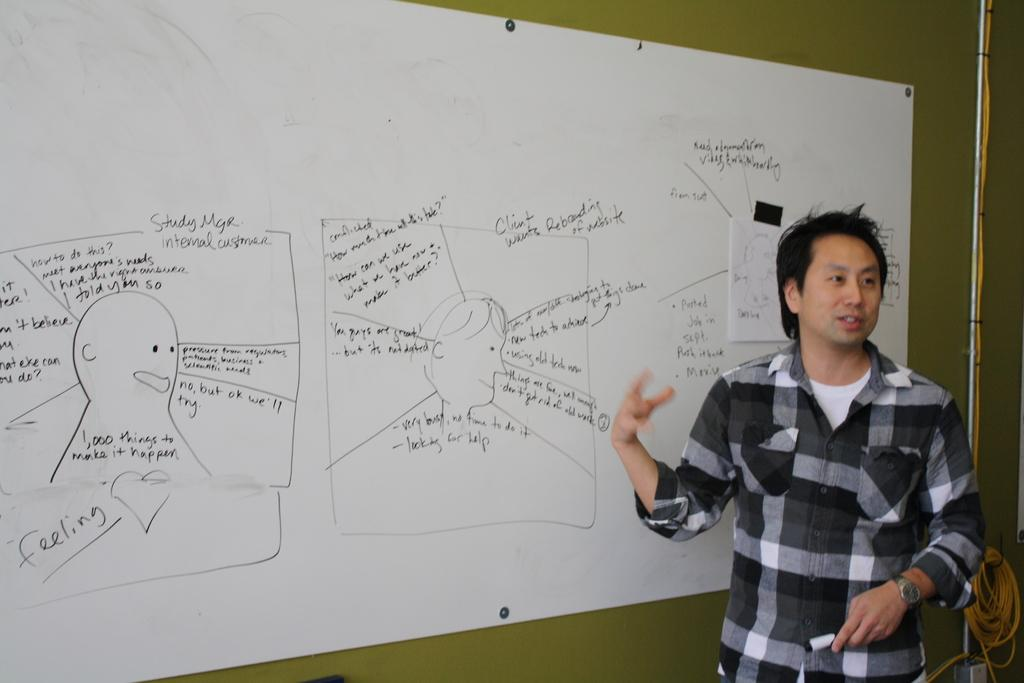<image>
Describe the image concisely. A man standing in front of a whiteboard with the word feeling written underneath the drawing of a person. 